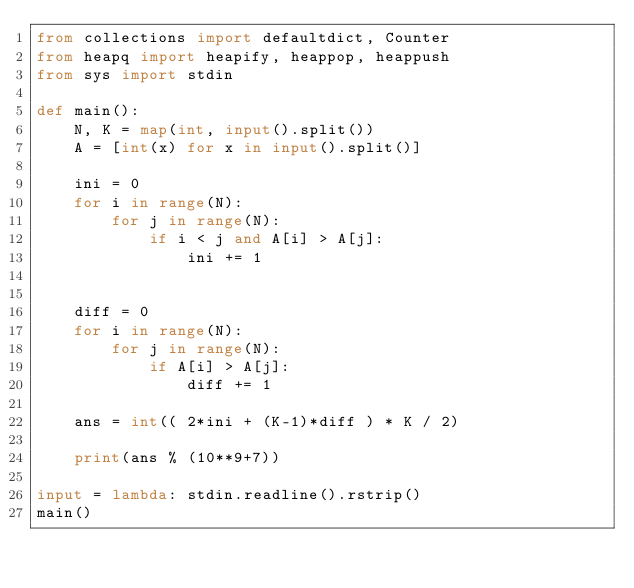Convert code to text. <code><loc_0><loc_0><loc_500><loc_500><_Python_>from collections import defaultdict, Counter
from heapq import heapify, heappop, heappush
from sys import stdin

def main():
    N, K = map(int, input().split())
    A = [int(x) for x in input().split()]

    ini = 0
    for i in range(N):
        for j in range(N):
            if i < j and A[i] > A[j]:
                ini += 1


    diff = 0
    for i in range(N):
        for j in range(N):
            if A[i] > A[j]:
                diff += 1

    ans = int(( 2*ini + (K-1)*diff ) * K / 2)

    print(ans % (10**9+7))

input = lambda: stdin.readline().rstrip()
main()</code> 